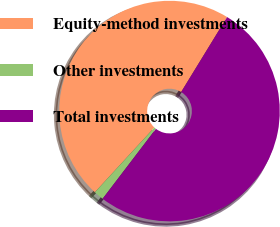Convert chart to OTSL. <chart><loc_0><loc_0><loc_500><loc_500><pie_chart><fcel>Equity-method investments<fcel>Other investments<fcel>Total investments<nl><fcel>46.92%<fcel>1.46%<fcel>51.62%<nl></chart> 